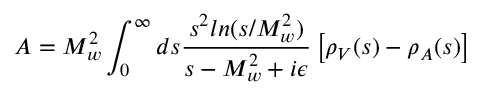Convert formula to latex. <formula><loc_0><loc_0><loc_500><loc_500>A = M _ { w } ^ { 2 } \int _ { 0 } ^ { \infty } d s { \frac { s ^ { 2 } \ln ( s / M _ { w } ^ { 2 } ) } { s - M _ { w } ^ { 2 } + i \epsilon } } \left [ \rho _ { V } ( s ) - \rho _ { A } ( s ) \right ]</formula> 